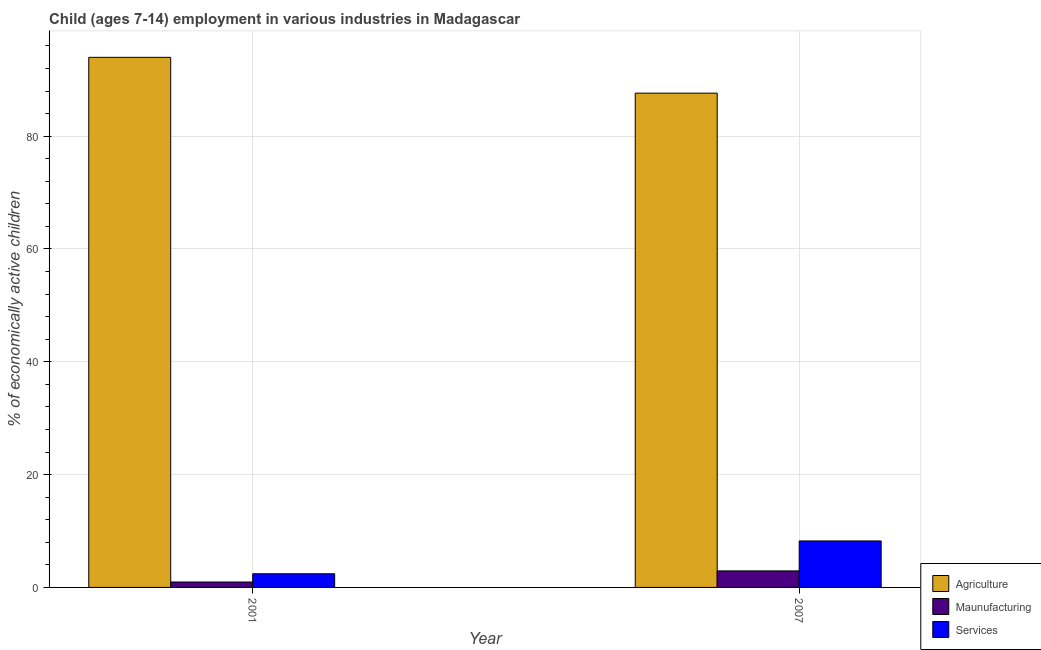How many different coloured bars are there?
Make the answer very short. 3. How many groups of bars are there?
Your answer should be compact. 2. Are the number of bars per tick equal to the number of legend labels?
Offer a terse response. Yes. What is the label of the 1st group of bars from the left?
Your answer should be compact. 2001. In how many cases, is the number of bars for a given year not equal to the number of legend labels?
Offer a terse response. 0. What is the percentage of economically active children in agriculture in 2001?
Your answer should be compact. 93.97. Across all years, what is the maximum percentage of economically active children in manufacturing?
Your answer should be compact. 2.93. Across all years, what is the minimum percentage of economically active children in manufacturing?
Make the answer very short. 0.96. What is the total percentage of economically active children in manufacturing in the graph?
Offer a terse response. 3.89. What is the difference between the percentage of economically active children in agriculture in 2001 and that in 2007?
Offer a terse response. 6.35. What is the difference between the percentage of economically active children in manufacturing in 2007 and the percentage of economically active children in agriculture in 2001?
Your answer should be very brief. 1.97. What is the average percentage of economically active children in services per year?
Provide a short and direct response. 5.33. In how many years, is the percentage of economically active children in agriculture greater than 32 %?
Make the answer very short. 2. What is the ratio of the percentage of economically active children in manufacturing in 2001 to that in 2007?
Your answer should be very brief. 0.33. What does the 2nd bar from the left in 2007 represents?
Make the answer very short. Maunufacturing. What does the 2nd bar from the right in 2001 represents?
Provide a succinct answer. Maunufacturing. Is it the case that in every year, the sum of the percentage of economically active children in agriculture and percentage of economically active children in manufacturing is greater than the percentage of economically active children in services?
Offer a terse response. Yes. Are all the bars in the graph horizontal?
Offer a very short reply. No. How many years are there in the graph?
Offer a very short reply. 2. What is the difference between two consecutive major ticks on the Y-axis?
Your answer should be very brief. 20. Are the values on the major ticks of Y-axis written in scientific E-notation?
Provide a succinct answer. No. Does the graph contain any zero values?
Ensure brevity in your answer.  No. Does the graph contain grids?
Your answer should be compact. Yes. How are the legend labels stacked?
Ensure brevity in your answer.  Vertical. What is the title of the graph?
Make the answer very short. Child (ages 7-14) employment in various industries in Madagascar. Does "Infant(female)" appear as one of the legend labels in the graph?
Provide a short and direct response. No. What is the label or title of the Y-axis?
Provide a succinct answer. % of economically active children. What is the % of economically active children of Agriculture in 2001?
Offer a terse response. 93.97. What is the % of economically active children of Maunufacturing in 2001?
Provide a succinct answer. 0.96. What is the % of economically active children in Services in 2001?
Make the answer very short. 2.42. What is the % of economically active children in Agriculture in 2007?
Keep it short and to the point. 87.62. What is the % of economically active children of Maunufacturing in 2007?
Keep it short and to the point. 2.93. What is the % of economically active children in Services in 2007?
Your answer should be very brief. 8.24. Across all years, what is the maximum % of economically active children of Agriculture?
Keep it short and to the point. 93.97. Across all years, what is the maximum % of economically active children in Maunufacturing?
Your answer should be compact. 2.93. Across all years, what is the maximum % of economically active children in Services?
Give a very brief answer. 8.24. Across all years, what is the minimum % of economically active children in Agriculture?
Keep it short and to the point. 87.62. Across all years, what is the minimum % of economically active children of Maunufacturing?
Offer a terse response. 0.96. Across all years, what is the minimum % of economically active children in Services?
Ensure brevity in your answer.  2.42. What is the total % of economically active children in Agriculture in the graph?
Make the answer very short. 181.59. What is the total % of economically active children of Maunufacturing in the graph?
Your answer should be very brief. 3.89. What is the total % of economically active children of Services in the graph?
Offer a terse response. 10.66. What is the difference between the % of economically active children in Agriculture in 2001 and that in 2007?
Keep it short and to the point. 6.35. What is the difference between the % of economically active children of Maunufacturing in 2001 and that in 2007?
Offer a terse response. -1.97. What is the difference between the % of economically active children in Services in 2001 and that in 2007?
Your answer should be compact. -5.82. What is the difference between the % of economically active children in Agriculture in 2001 and the % of economically active children in Maunufacturing in 2007?
Keep it short and to the point. 91.04. What is the difference between the % of economically active children in Agriculture in 2001 and the % of economically active children in Services in 2007?
Make the answer very short. 85.73. What is the difference between the % of economically active children of Maunufacturing in 2001 and the % of economically active children of Services in 2007?
Make the answer very short. -7.28. What is the average % of economically active children of Agriculture per year?
Your answer should be very brief. 90.8. What is the average % of economically active children in Maunufacturing per year?
Offer a very short reply. 1.95. What is the average % of economically active children in Services per year?
Keep it short and to the point. 5.33. In the year 2001, what is the difference between the % of economically active children in Agriculture and % of economically active children in Maunufacturing?
Provide a short and direct response. 93.01. In the year 2001, what is the difference between the % of economically active children of Agriculture and % of economically active children of Services?
Your response must be concise. 91.55. In the year 2001, what is the difference between the % of economically active children in Maunufacturing and % of economically active children in Services?
Give a very brief answer. -1.46. In the year 2007, what is the difference between the % of economically active children in Agriculture and % of economically active children in Maunufacturing?
Keep it short and to the point. 84.69. In the year 2007, what is the difference between the % of economically active children of Agriculture and % of economically active children of Services?
Make the answer very short. 79.38. In the year 2007, what is the difference between the % of economically active children of Maunufacturing and % of economically active children of Services?
Keep it short and to the point. -5.31. What is the ratio of the % of economically active children in Agriculture in 2001 to that in 2007?
Your answer should be very brief. 1.07. What is the ratio of the % of economically active children of Maunufacturing in 2001 to that in 2007?
Provide a short and direct response. 0.33. What is the ratio of the % of economically active children in Services in 2001 to that in 2007?
Offer a very short reply. 0.29. What is the difference between the highest and the second highest % of economically active children of Agriculture?
Provide a succinct answer. 6.35. What is the difference between the highest and the second highest % of economically active children of Maunufacturing?
Offer a terse response. 1.97. What is the difference between the highest and the second highest % of economically active children in Services?
Give a very brief answer. 5.82. What is the difference between the highest and the lowest % of economically active children in Agriculture?
Offer a very short reply. 6.35. What is the difference between the highest and the lowest % of economically active children in Maunufacturing?
Make the answer very short. 1.97. What is the difference between the highest and the lowest % of economically active children in Services?
Provide a succinct answer. 5.82. 